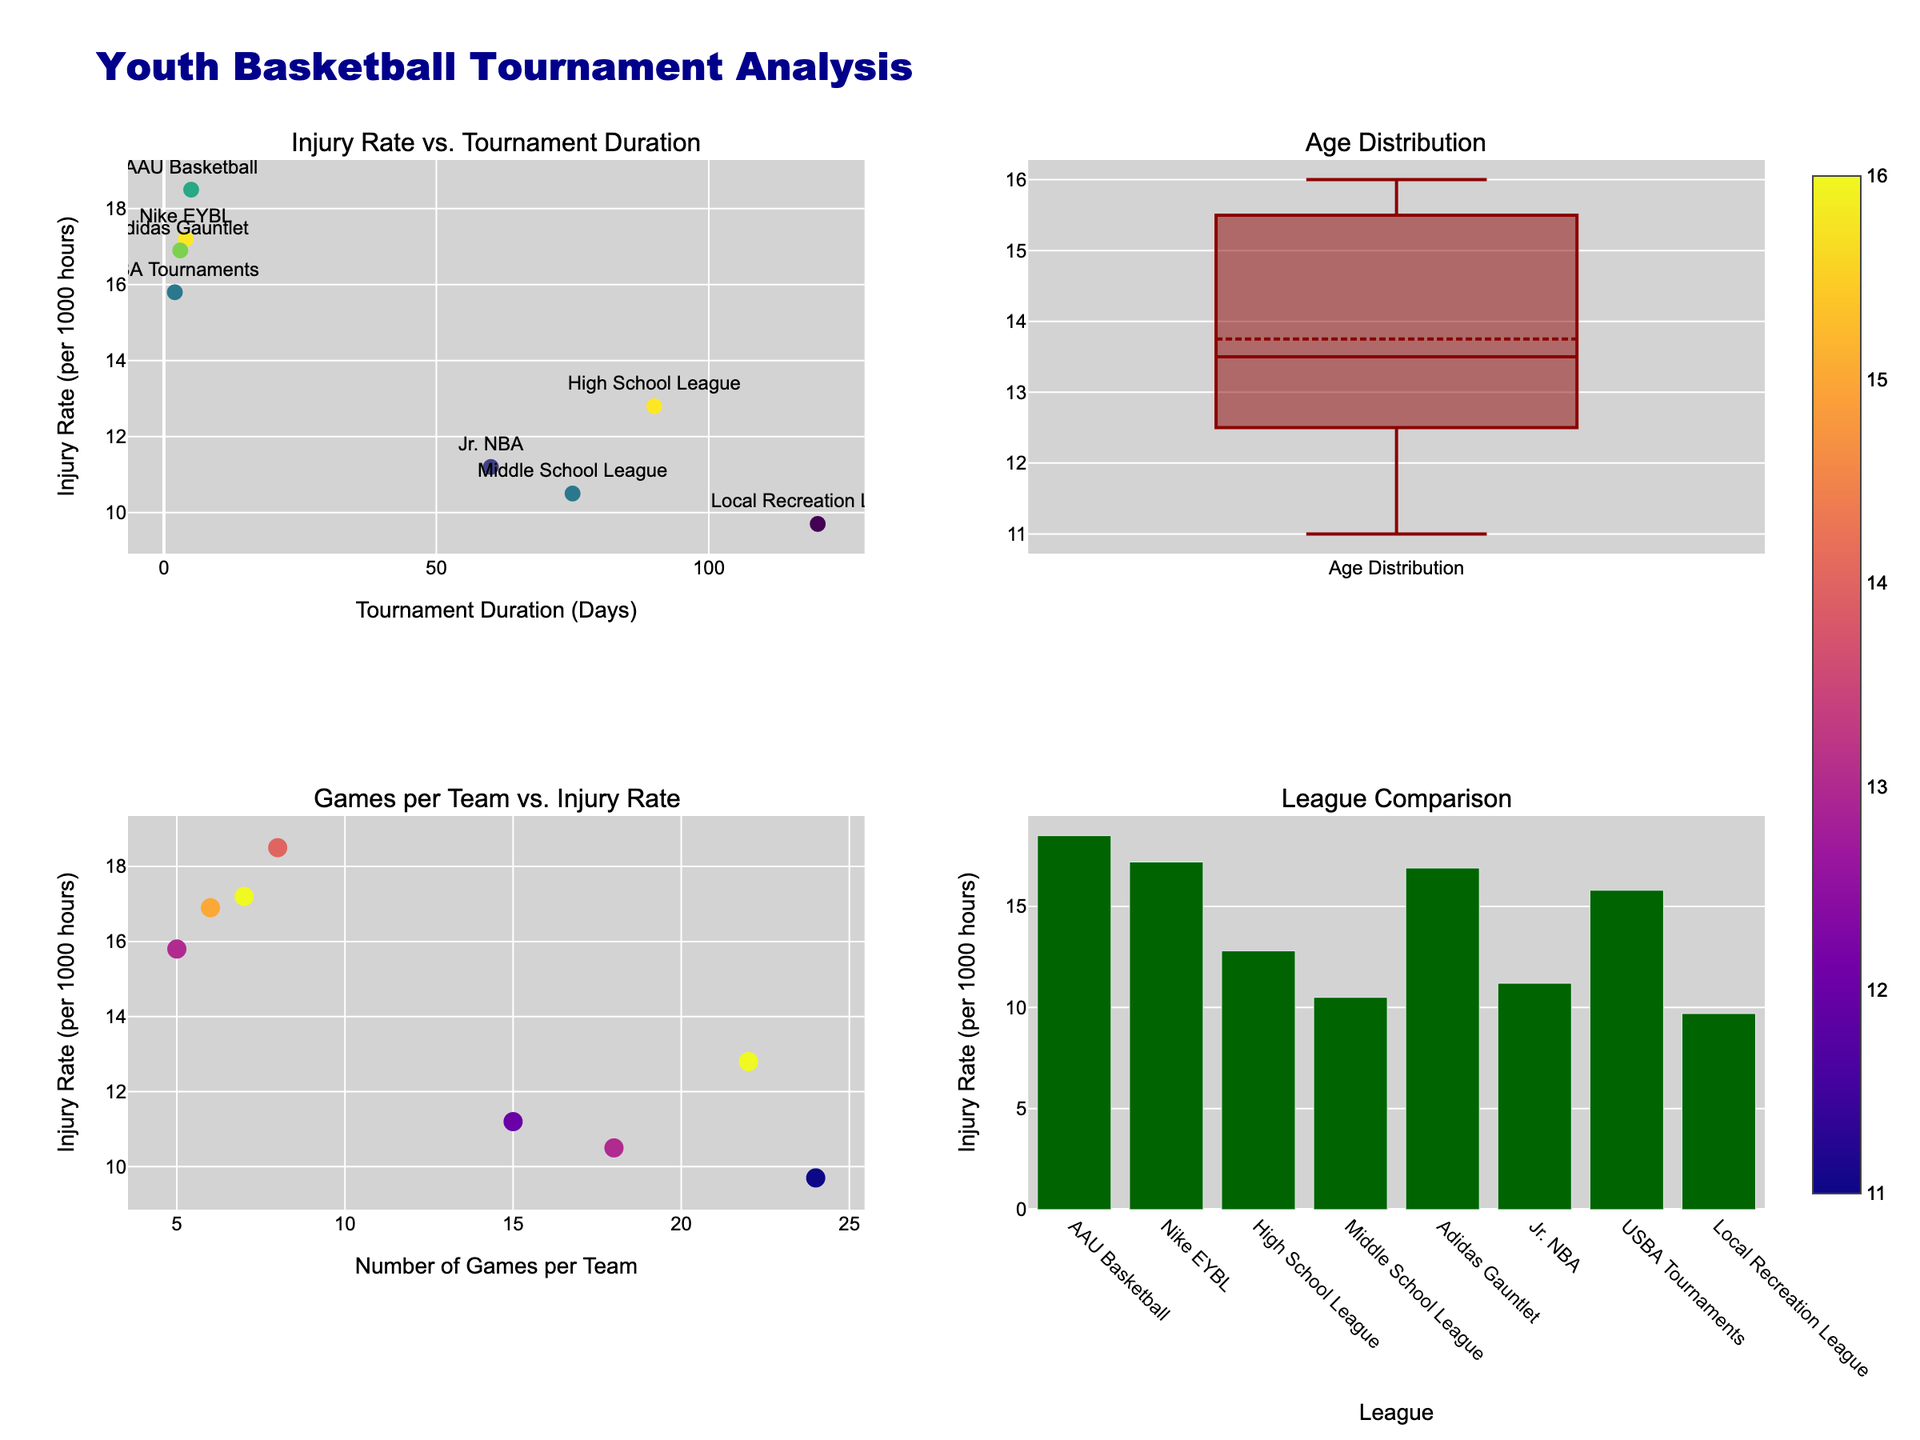Which league has the highest injury rate? By looking at the bar plot in the "League Comparison" subplot, we can see the injury rates for each league. AAU Basketball has the highest bar with an injury rate of 18.5 per 1000 hours.
Answer: AAU Basketball What is the average age for participants in the Jr. NBA league? Refer to the data labels on the "League Comparison" subplot where Jr. NBA is listed. The average age for Jr. NBA participants is 12.
Answer: 12 Which league has the lowest injury rate? From the "League Comparison" subplot, we can identify the league with the shortest bar. Local Recreation League has the lowest injury rate, with a value of 9.7 per 1000 hours.
Answer: Local Recreation League How does Nike EYBL compare to High School League in terms of injury rates? By examining the "League Comparison" subplot, we can compare the heights of the bars for Nike EYBL and High School League. Nike EYBL has an injury rate of 17.2, while High School League has an injury rate of 12.8.
Answer: Nike EYBL has a higher injury rate than High School League Is there a correlation between the number of games per team and the injury rate? In the scatter plot "Games per Team vs. Injury Rate," we observe the distribution of points along the axes. There is a little correlation, as leagues with various game counts have differing injury rates.
Answer: There is little correlation Which league has the longest tournament duration, and what is its injury rate? From the scatter plot "Injury Rate vs. Tournament Duration," we can identify the tournament duration for each league. Local Recreation League has the longest duration of 120 days and an injury rate of 9.7 per 1000 hours.
Answer: Local Recreation League, 9.7 per 1000 hours What is the median age of tournament participants? In the "Age Distribution" box plot, look at the median line within the box. The median age of participants is 14.
Answer: 14 Which league hosts the most number of games per team? By checking the scatter plot "Games per Team vs. Injury Rate," we can find that Local Recreation League hosts the most number of games per team, which is 24.
Answer: Local Recreation League Are younger leagues more prone to injuries according to the "Age Distribution" box plot? Examining the "Age Distribution" box plot, it seems that the average ages are not directly proportional to the injury rates. Younger leagues do not necessarily have higher injury rates.
Answer: Not necessarily Which leagues fall within the 12-14 age range according to the box plot? By looking at the spread of ages in the "Age Distribution" box plot, we can identify the leagues within this range. They include AAU Basketball, USBA Tournaments, and Jr. NBA.
Answer: AAU Basketball, USBA Tournaments, Jr. NBA 